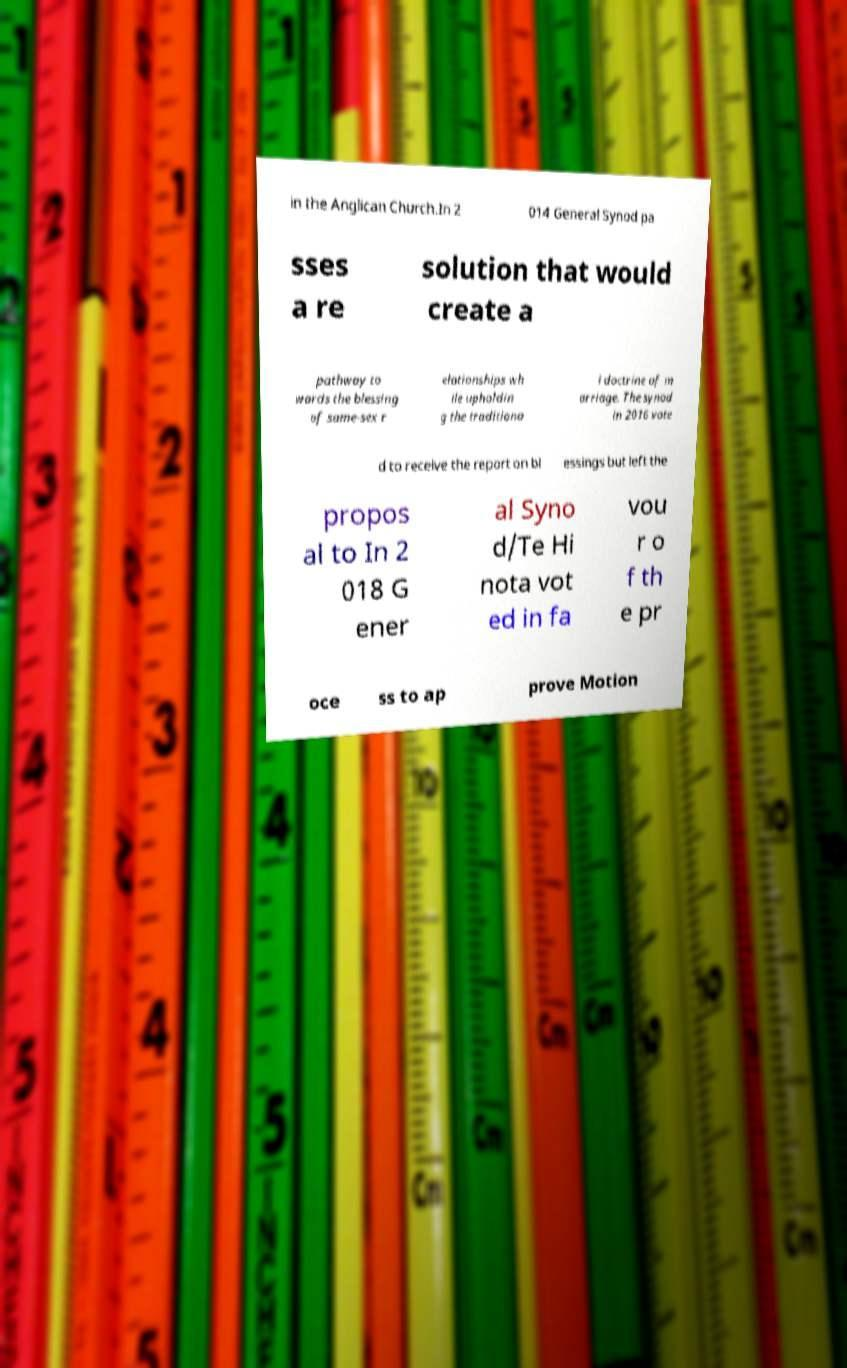There's text embedded in this image that I need extracted. Can you transcribe it verbatim? in the Anglican Church.In 2 014 General Synod pa sses a re solution that would create a pathway to wards the blessing of same-sex r elationships wh ile upholdin g the traditiona l doctrine of m arriage. The synod in 2016 vote d to receive the report on bl essings but left the propos al to In 2 018 G ener al Syno d/Te Hi nota vot ed in fa vou r o f th e pr oce ss to ap prove Motion 